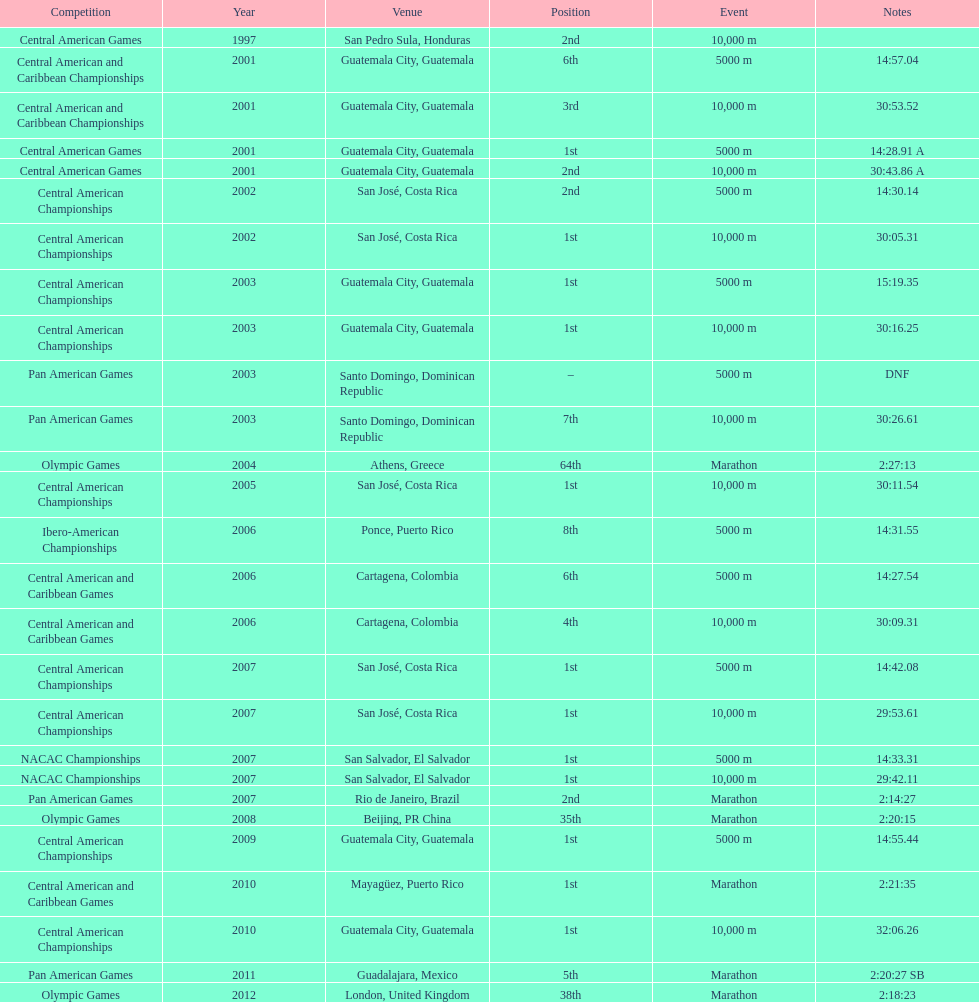What was the first competition this competitor competed in? Central American Games. 